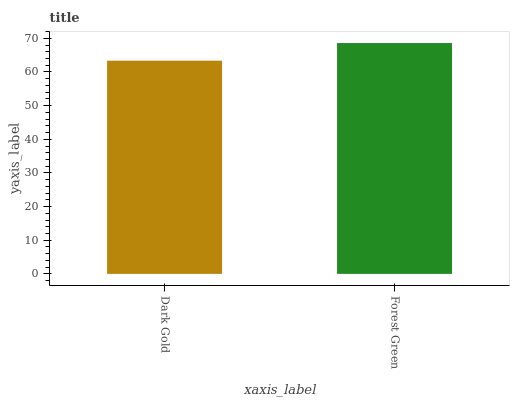Is Forest Green the minimum?
Answer yes or no. No. Is Forest Green greater than Dark Gold?
Answer yes or no. Yes. Is Dark Gold less than Forest Green?
Answer yes or no. Yes. Is Dark Gold greater than Forest Green?
Answer yes or no. No. Is Forest Green less than Dark Gold?
Answer yes or no. No. Is Forest Green the high median?
Answer yes or no. Yes. Is Dark Gold the low median?
Answer yes or no. Yes. Is Dark Gold the high median?
Answer yes or no. No. Is Forest Green the low median?
Answer yes or no. No. 